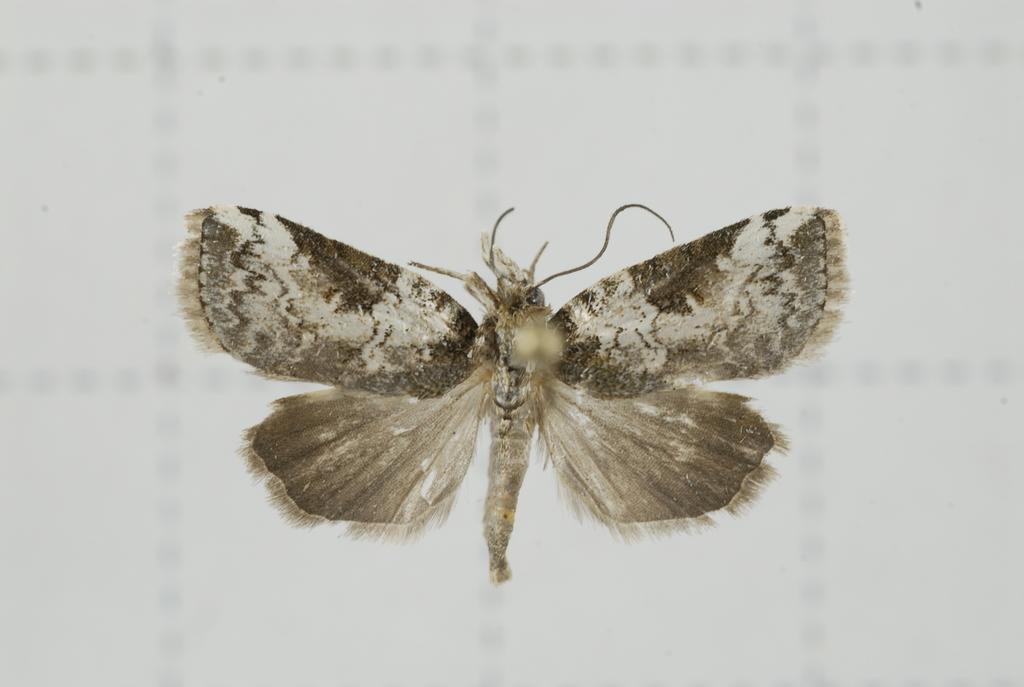Please provide a concise description of this image. In this picture I can see a moth and I can see white color background. 